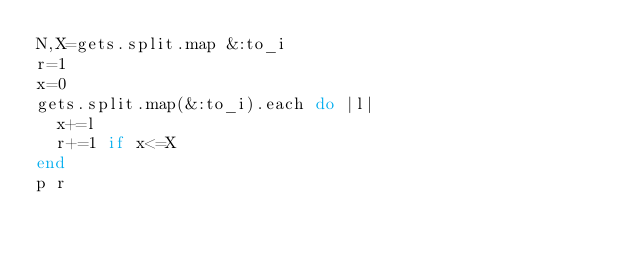Convert code to text. <code><loc_0><loc_0><loc_500><loc_500><_Ruby_>N,X=gets.split.map &:to_i
r=1
x=0
gets.split.map(&:to_i).each do |l|
  x+=l
  r+=1 if x<=X
end
p r
</code> 